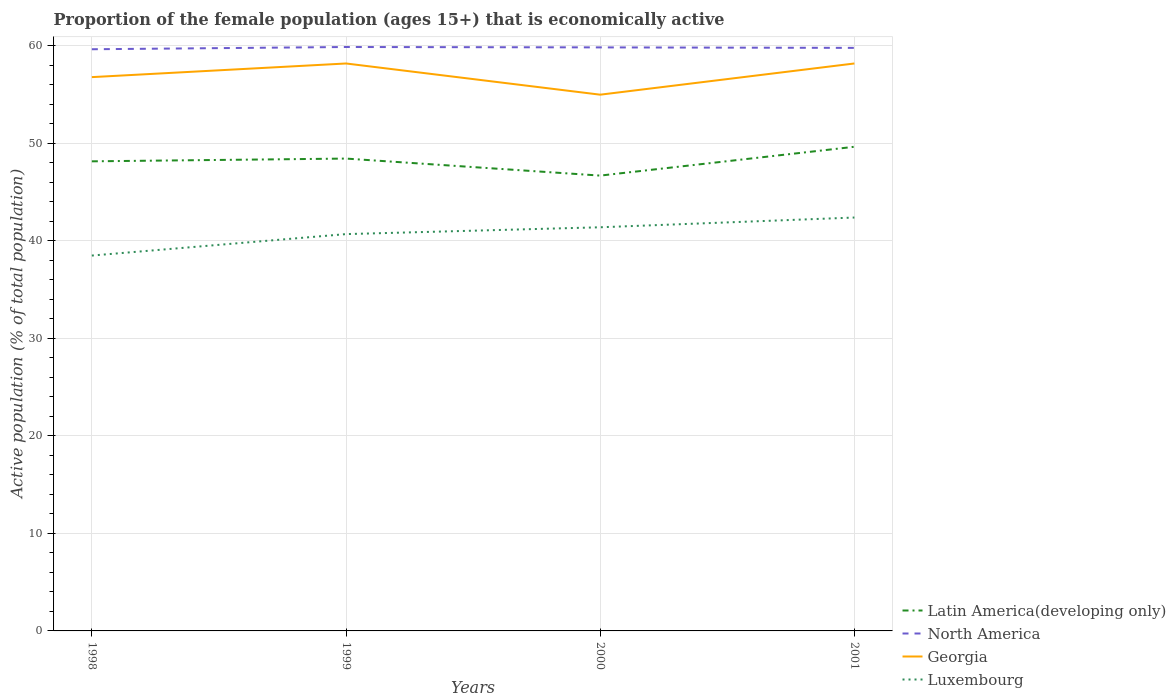How many different coloured lines are there?
Offer a very short reply. 4. Does the line corresponding to Luxembourg intersect with the line corresponding to North America?
Make the answer very short. No. Is the number of lines equal to the number of legend labels?
Provide a short and direct response. Yes. In which year was the proportion of the female population that is economically active in Luxembourg maximum?
Ensure brevity in your answer.  1998. What is the total proportion of the female population that is economically active in Latin America(developing only) in the graph?
Offer a very short reply. 1.46. What is the difference between the highest and the second highest proportion of the female population that is economically active in Latin America(developing only)?
Keep it short and to the point. 2.96. What is the difference between the highest and the lowest proportion of the female population that is economically active in Luxembourg?
Make the answer very short. 2. How many years are there in the graph?
Give a very brief answer. 4. Are the values on the major ticks of Y-axis written in scientific E-notation?
Your answer should be very brief. No. Does the graph contain any zero values?
Make the answer very short. No. Where does the legend appear in the graph?
Offer a very short reply. Bottom right. How are the legend labels stacked?
Ensure brevity in your answer.  Vertical. What is the title of the graph?
Provide a short and direct response. Proportion of the female population (ages 15+) that is economically active. Does "Bosnia and Herzegovina" appear as one of the legend labels in the graph?
Make the answer very short. No. What is the label or title of the Y-axis?
Keep it short and to the point. Active population (% of total population). What is the Active population (% of total population) in Latin America(developing only) in 1998?
Ensure brevity in your answer.  48.16. What is the Active population (% of total population) in North America in 1998?
Offer a very short reply. 59.66. What is the Active population (% of total population) in Georgia in 1998?
Keep it short and to the point. 56.8. What is the Active population (% of total population) in Luxembourg in 1998?
Provide a short and direct response. 38.5. What is the Active population (% of total population) of Latin America(developing only) in 1999?
Provide a short and direct response. 48.45. What is the Active population (% of total population) of North America in 1999?
Your response must be concise. 59.89. What is the Active population (% of total population) of Georgia in 1999?
Offer a terse response. 58.2. What is the Active population (% of total population) of Luxembourg in 1999?
Make the answer very short. 40.7. What is the Active population (% of total population) in Latin America(developing only) in 2000?
Provide a succinct answer. 46.7. What is the Active population (% of total population) of North America in 2000?
Your response must be concise. 59.85. What is the Active population (% of total population) in Georgia in 2000?
Your answer should be very brief. 55. What is the Active population (% of total population) in Luxembourg in 2000?
Provide a succinct answer. 41.4. What is the Active population (% of total population) of Latin America(developing only) in 2001?
Your response must be concise. 49.66. What is the Active population (% of total population) in North America in 2001?
Your answer should be compact. 59.8. What is the Active population (% of total population) of Georgia in 2001?
Keep it short and to the point. 58.2. What is the Active population (% of total population) of Luxembourg in 2001?
Provide a short and direct response. 42.4. Across all years, what is the maximum Active population (% of total population) in Latin America(developing only)?
Your response must be concise. 49.66. Across all years, what is the maximum Active population (% of total population) of North America?
Your response must be concise. 59.89. Across all years, what is the maximum Active population (% of total population) of Georgia?
Your response must be concise. 58.2. Across all years, what is the maximum Active population (% of total population) in Luxembourg?
Your response must be concise. 42.4. Across all years, what is the minimum Active population (% of total population) of Latin America(developing only)?
Give a very brief answer. 46.7. Across all years, what is the minimum Active population (% of total population) of North America?
Your response must be concise. 59.66. Across all years, what is the minimum Active population (% of total population) in Georgia?
Your response must be concise. 55. Across all years, what is the minimum Active population (% of total population) of Luxembourg?
Your answer should be compact. 38.5. What is the total Active population (% of total population) in Latin America(developing only) in the graph?
Give a very brief answer. 192.97. What is the total Active population (% of total population) in North America in the graph?
Your answer should be very brief. 239.2. What is the total Active population (% of total population) in Georgia in the graph?
Provide a succinct answer. 228.2. What is the total Active population (% of total population) in Luxembourg in the graph?
Your answer should be compact. 163. What is the difference between the Active population (% of total population) in Latin America(developing only) in 1998 and that in 1999?
Provide a succinct answer. -0.28. What is the difference between the Active population (% of total population) in North America in 1998 and that in 1999?
Offer a very short reply. -0.23. What is the difference between the Active population (% of total population) of Luxembourg in 1998 and that in 1999?
Offer a terse response. -2.2. What is the difference between the Active population (% of total population) of Latin America(developing only) in 1998 and that in 2000?
Provide a succinct answer. 1.46. What is the difference between the Active population (% of total population) in North America in 1998 and that in 2000?
Your answer should be compact. -0.19. What is the difference between the Active population (% of total population) in Latin America(developing only) in 1998 and that in 2001?
Offer a terse response. -1.49. What is the difference between the Active population (% of total population) in North America in 1998 and that in 2001?
Your answer should be very brief. -0.14. What is the difference between the Active population (% of total population) of Georgia in 1998 and that in 2001?
Offer a terse response. -1.4. What is the difference between the Active population (% of total population) in Latin America(developing only) in 1999 and that in 2000?
Make the answer very short. 1.75. What is the difference between the Active population (% of total population) of North America in 1999 and that in 2000?
Your response must be concise. 0.04. What is the difference between the Active population (% of total population) of Luxembourg in 1999 and that in 2000?
Keep it short and to the point. -0.7. What is the difference between the Active population (% of total population) in Latin America(developing only) in 1999 and that in 2001?
Keep it short and to the point. -1.21. What is the difference between the Active population (% of total population) in North America in 1999 and that in 2001?
Your answer should be very brief. 0.09. What is the difference between the Active population (% of total population) of Georgia in 1999 and that in 2001?
Make the answer very short. 0. What is the difference between the Active population (% of total population) in Luxembourg in 1999 and that in 2001?
Make the answer very short. -1.7. What is the difference between the Active population (% of total population) of Latin America(developing only) in 2000 and that in 2001?
Your answer should be compact. -2.96. What is the difference between the Active population (% of total population) in North America in 2000 and that in 2001?
Your response must be concise. 0.05. What is the difference between the Active population (% of total population) of Luxembourg in 2000 and that in 2001?
Provide a short and direct response. -1. What is the difference between the Active population (% of total population) in Latin America(developing only) in 1998 and the Active population (% of total population) in North America in 1999?
Offer a very short reply. -11.73. What is the difference between the Active population (% of total population) in Latin America(developing only) in 1998 and the Active population (% of total population) in Georgia in 1999?
Offer a very short reply. -10.04. What is the difference between the Active population (% of total population) in Latin America(developing only) in 1998 and the Active population (% of total population) in Luxembourg in 1999?
Provide a short and direct response. 7.46. What is the difference between the Active population (% of total population) in North America in 1998 and the Active population (% of total population) in Georgia in 1999?
Offer a terse response. 1.46. What is the difference between the Active population (% of total population) in North America in 1998 and the Active population (% of total population) in Luxembourg in 1999?
Provide a short and direct response. 18.96. What is the difference between the Active population (% of total population) of Georgia in 1998 and the Active population (% of total population) of Luxembourg in 1999?
Your answer should be very brief. 16.1. What is the difference between the Active population (% of total population) of Latin America(developing only) in 1998 and the Active population (% of total population) of North America in 2000?
Make the answer very short. -11.69. What is the difference between the Active population (% of total population) of Latin America(developing only) in 1998 and the Active population (% of total population) of Georgia in 2000?
Your response must be concise. -6.84. What is the difference between the Active population (% of total population) of Latin America(developing only) in 1998 and the Active population (% of total population) of Luxembourg in 2000?
Ensure brevity in your answer.  6.76. What is the difference between the Active population (% of total population) of North America in 1998 and the Active population (% of total population) of Georgia in 2000?
Provide a short and direct response. 4.66. What is the difference between the Active population (% of total population) in North America in 1998 and the Active population (% of total population) in Luxembourg in 2000?
Keep it short and to the point. 18.26. What is the difference between the Active population (% of total population) in Georgia in 1998 and the Active population (% of total population) in Luxembourg in 2000?
Ensure brevity in your answer.  15.4. What is the difference between the Active population (% of total population) in Latin America(developing only) in 1998 and the Active population (% of total population) in North America in 2001?
Keep it short and to the point. -11.64. What is the difference between the Active population (% of total population) in Latin America(developing only) in 1998 and the Active population (% of total population) in Georgia in 2001?
Your answer should be very brief. -10.04. What is the difference between the Active population (% of total population) of Latin America(developing only) in 1998 and the Active population (% of total population) of Luxembourg in 2001?
Offer a terse response. 5.76. What is the difference between the Active population (% of total population) in North America in 1998 and the Active population (% of total population) in Georgia in 2001?
Offer a very short reply. 1.46. What is the difference between the Active population (% of total population) in North America in 1998 and the Active population (% of total population) in Luxembourg in 2001?
Give a very brief answer. 17.26. What is the difference between the Active population (% of total population) in Georgia in 1998 and the Active population (% of total population) in Luxembourg in 2001?
Your answer should be very brief. 14.4. What is the difference between the Active population (% of total population) in Latin America(developing only) in 1999 and the Active population (% of total population) in North America in 2000?
Offer a terse response. -11.4. What is the difference between the Active population (% of total population) of Latin America(developing only) in 1999 and the Active population (% of total population) of Georgia in 2000?
Make the answer very short. -6.55. What is the difference between the Active population (% of total population) in Latin America(developing only) in 1999 and the Active population (% of total population) in Luxembourg in 2000?
Provide a succinct answer. 7.05. What is the difference between the Active population (% of total population) of North America in 1999 and the Active population (% of total population) of Georgia in 2000?
Your answer should be very brief. 4.89. What is the difference between the Active population (% of total population) in North America in 1999 and the Active population (% of total population) in Luxembourg in 2000?
Keep it short and to the point. 18.49. What is the difference between the Active population (% of total population) in Latin America(developing only) in 1999 and the Active population (% of total population) in North America in 2001?
Ensure brevity in your answer.  -11.35. What is the difference between the Active population (% of total population) of Latin America(developing only) in 1999 and the Active population (% of total population) of Georgia in 2001?
Ensure brevity in your answer.  -9.75. What is the difference between the Active population (% of total population) in Latin America(developing only) in 1999 and the Active population (% of total population) in Luxembourg in 2001?
Provide a succinct answer. 6.05. What is the difference between the Active population (% of total population) of North America in 1999 and the Active population (% of total population) of Georgia in 2001?
Your answer should be compact. 1.69. What is the difference between the Active population (% of total population) of North America in 1999 and the Active population (% of total population) of Luxembourg in 2001?
Make the answer very short. 17.49. What is the difference between the Active population (% of total population) in Georgia in 1999 and the Active population (% of total population) in Luxembourg in 2001?
Give a very brief answer. 15.8. What is the difference between the Active population (% of total population) in Latin America(developing only) in 2000 and the Active population (% of total population) in North America in 2001?
Your response must be concise. -13.1. What is the difference between the Active population (% of total population) of Latin America(developing only) in 2000 and the Active population (% of total population) of Georgia in 2001?
Your answer should be very brief. -11.5. What is the difference between the Active population (% of total population) in Latin America(developing only) in 2000 and the Active population (% of total population) in Luxembourg in 2001?
Your response must be concise. 4.3. What is the difference between the Active population (% of total population) of North America in 2000 and the Active population (% of total population) of Georgia in 2001?
Make the answer very short. 1.65. What is the difference between the Active population (% of total population) of North America in 2000 and the Active population (% of total population) of Luxembourg in 2001?
Keep it short and to the point. 17.45. What is the difference between the Active population (% of total population) of Georgia in 2000 and the Active population (% of total population) of Luxembourg in 2001?
Offer a terse response. 12.6. What is the average Active population (% of total population) of Latin America(developing only) per year?
Offer a very short reply. 48.24. What is the average Active population (% of total population) in North America per year?
Offer a terse response. 59.8. What is the average Active population (% of total population) of Georgia per year?
Provide a succinct answer. 57.05. What is the average Active population (% of total population) in Luxembourg per year?
Ensure brevity in your answer.  40.75. In the year 1998, what is the difference between the Active population (% of total population) of Latin America(developing only) and Active population (% of total population) of North America?
Your response must be concise. -11.5. In the year 1998, what is the difference between the Active population (% of total population) of Latin America(developing only) and Active population (% of total population) of Georgia?
Your response must be concise. -8.64. In the year 1998, what is the difference between the Active population (% of total population) of Latin America(developing only) and Active population (% of total population) of Luxembourg?
Keep it short and to the point. 9.66. In the year 1998, what is the difference between the Active population (% of total population) in North America and Active population (% of total population) in Georgia?
Ensure brevity in your answer.  2.86. In the year 1998, what is the difference between the Active population (% of total population) in North America and Active population (% of total population) in Luxembourg?
Provide a succinct answer. 21.16. In the year 1999, what is the difference between the Active population (% of total population) of Latin America(developing only) and Active population (% of total population) of North America?
Your answer should be very brief. -11.44. In the year 1999, what is the difference between the Active population (% of total population) of Latin America(developing only) and Active population (% of total population) of Georgia?
Keep it short and to the point. -9.75. In the year 1999, what is the difference between the Active population (% of total population) in Latin America(developing only) and Active population (% of total population) in Luxembourg?
Provide a short and direct response. 7.75. In the year 1999, what is the difference between the Active population (% of total population) of North America and Active population (% of total population) of Georgia?
Give a very brief answer. 1.69. In the year 1999, what is the difference between the Active population (% of total population) of North America and Active population (% of total population) of Luxembourg?
Make the answer very short. 19.19. In the year 1999, what is the difference between the Active population (% of total population) in Georgia and Active population (% of total population) in Luxembourg?
Offer a terse response. 17.5. In the year 2000, what is the difference between the Active population (% of total population) of Latin America(developing only) and Active population (% of total population) of North America?
Your response must be concise. -13.15. In the year 2000, what is the difference between the Active population (% of total population) in Latin America(developing only) and Active population (% of total population) in Georgia?
Your response must be concise. -8.3. In the year 2000, what is the difference between the Active population (% of total population) in Latin America(developing only) and Active population (% of total population) in Luxembourg?
Give a very brief answer. 5.3. In the year 2000, what is the difference between the Active population (% of total population) of North America and Active population (% of total population) of Georgia?
Keep it short and to the point. 4.85. In the year 2000, what is the difference between the Active population (% of total population) in North America and Active population (% of total population) in Luxembourg?
Keep it short and to the point. 18.45. In the year 2001, what is the difference between the Active population (% of total population) in Latin America(developing only) and Active population (% of total population) in North America?
Offer a very short reply. -10.14. In the year 2001, what is the difference between the Active population (% of total population) of Latin America(developing only) and Active population (% of total population) of Georgia?
Provide a succinct answer. -8.54. In the year 2001, what is the difference between the Active population (% of total population) in Latin America(developing only) and Active population (% of total population) in Luxembourg?
Provide a short and direct response. 7.26. In the year 2001, what is the difference between the Active population (% of total population) in North America and Active population (% of total population) in Luxembourg?
Offer a terse response. 17.4. What is the ratio of the Active population (% of total population) in Latin America(developing only) in 1998 to that in 1999?
Your response must be concise. 0.99. What is the ratio of the Active population (% of total population) in Georgia in 1998 to that in 1999?
Offer a very short reply. 0.98. What is the ratio of the Active population (% of total population) in Luxembourg in 1998 to that in 1999?
Your response must be concise. 0.95. What is the ratio of the Active population (% of total population) in Latin America(developing only) in 1998 to that in 2000?
Provide a succinct answer. 1.03. What is the ratio of the Active population (% of total population) of North America in 1998 to that in 2000?
Your response must be concise. 1. What is the ratio of the Active population (% of total population) of Georgia in 1998 to that in 2000?
Ensure brevity in your answer.  1.03. What is the ratio of the Active population (% of total population) in Latin America(developing only) in 1998 to that in 2001?
Offer a terse response. 0.97. What is the ratio of the Active population (% of total population) of North America in 1998 to that in 2001?
Your answer should be very brief. 1. What is the ratio of the Active population (% of total population) of Georgia in 1998 to that in 2001?
Your answer should be compact. 0.98. What is the ratio of the Active population (% of total population) of Luxembourg in 1998 to that in 2001?
Offer a very short reply. 0.91. What is the ratio of the Active population (% of total population) of Latin America(developing only) in 1999 to that in 2000?
Keep it short and to the point. 1.04. What is the ratio of the Active population (% of total population) of Georgia in 1999 to that in 2000?
Offer a very short reply. 1.06. What is the ratio of the Active population (% of total population) of Luxembourg in 1999 to that in 2000?
Provide a short and direct response. 0.98. What is the ratio of the Active population (% of total population) in Latin America(developing only) in 1999 to that in 2001?
Offer a terse response. 0.98. What is the ratio of the Active population (% of total population) in North America in 1999 to that in 2001?
Ensure brevity in your answer.  1. What is the ratio of the Active population (% of total population) of Georgia in 1999 to that in 2001?
Ensure brevity in your answer.  1. What is the ratio of the Active population (% of total population) in Luxembourg in 1999 to that in 2001?
Provide a succinct answer. 0.96. What is the ratio of the Active population (% of total population) in Latin America(developing only) in 2000 to that in 2001?
Ensure brevity in your answer.  0.94. What is the ratio of the Active population (% of total population) of North America in 2000 to that in 2001?
Offer a terse response. 1. What is the ratio of the Active population (% of total population) of Georgia in 2000 to that in 2001?
Keep it short and to the point. 0.94. What is the ratio of the Active population (% of total population) of Luxembourg in 2000 to that in 2001?
Your answer should be very brief. 0.98. What is the difference between the highest and the second highest Active population (% of total population) in Latin America(developing only)?
Give a very brief answer. 1.21. What is the difference between the highest and the second highest Active population (% of total population) in North America?
Ensure brevity in your answer.  0.04. What is the difference between the highest and the second highest Active population (% of total population) in Luxembourg?
Give a very brief answer. 1. What is the difference between the highest and the lowest Active population (% of total population) in Latin America(developing only)?
Your response must be concise. 2.96. What is the difference between the highest and the lowest Active population (% of total population) in North America?
Your answer should be compact. 0.23. What is the difference between the highest and the lowest Active population (% of total population) of Luxembourg?
Ensure brevity in your answer.  3.9. 